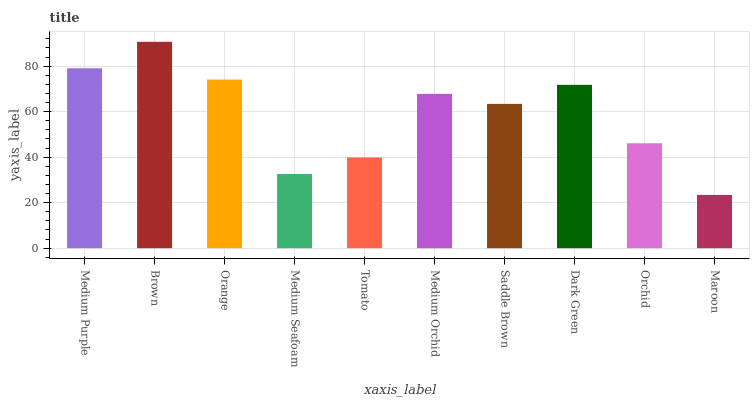Is Maroon the minimum?
Answer yes or no. Yes. Is Brown the maximum?
Answer yes or no. Yes. Is Orange the minimum?
Answer yes or no. No. Is Orange the maximum?
Answer yes or no. No. Is Brown greater than Orange?
Answer yes or no. Yes. Is Orange less than Brown?
Answer yes or no. Yes. Is Orange greater than Brown?
Answer yes or no. No. Is Brown less than Orange?
Answer yes or no. No. Is Medium Orchid the high median?
Answer yes or no. Yes. Is Saddle Brown the low median?
Answer yes or no. Yes. Is Orchid the high median?
Answer yes or no. No. Is Dark Green the low median?
Answer yes or no. No. 